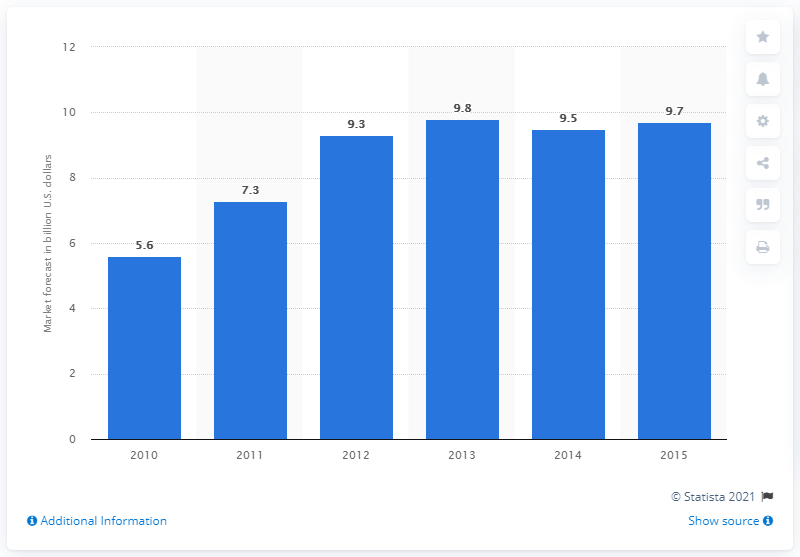Draw attention to some important aspects in this diagram. The estimated volume of the U.S. smart grid market in 2015 was 9.7. 